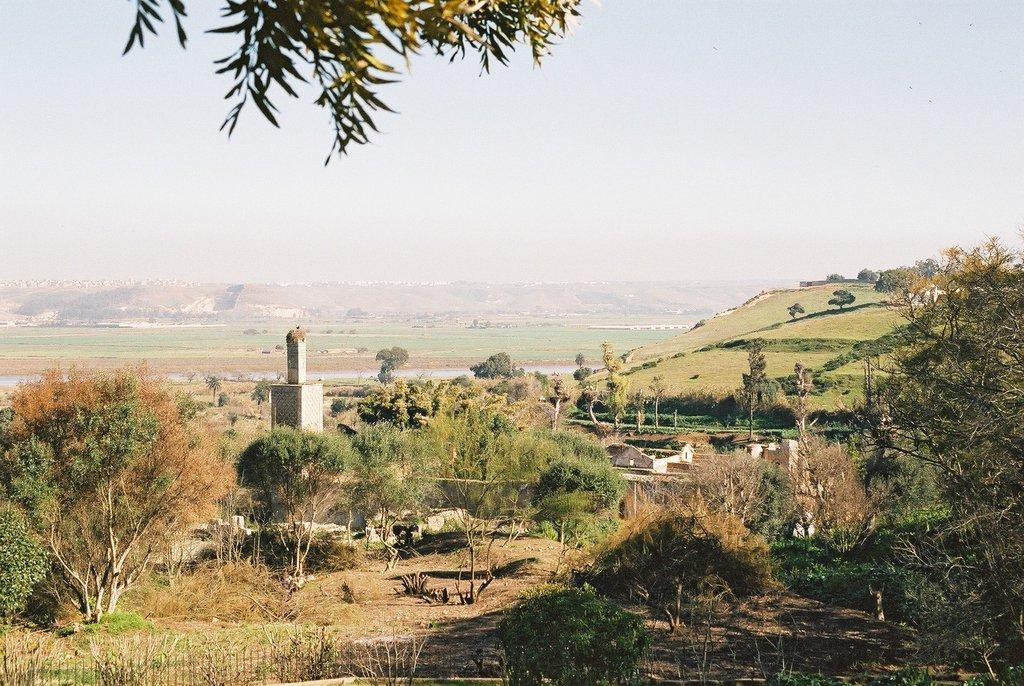What type of structures are present in the image? There is a group of buildings in the image. How are the buildings positioned in relation to the ground? The buildings are placed on the ground. What can be seen in the background of the image? There is a group of trees and mountains visible in the background of the image. What else is visible in the background of the image? The sky is visible in the background of the image. What month is it in the image? The month cannot be determined from the image, as there is no information about the time of year or any seasonal indicators present. 